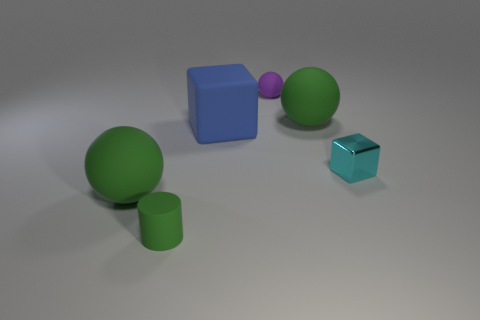Is there a large rubber object that has the same color as the cylinder?
Ensure brevity in your answer.  Yes. There is a rubber cylinder; is it the same color as the sphere that is in front of the cyan thing?
Make the answer very short. Yes. Are there the same number of large green spheres to the right of the tiny cyan block and small green metal cylinders?
Provide a succinct answer. Yes. What number of spheres have the same size as the cyan thing?
Give a very brief answer. 1. Are there any green cylinders?
Your answer should be compact. Yes. There is a large object in front of the blue rubber object; is its shape the same as the big green object that is behind the cyan cube?
Provide a short and direct response. Yes. How many big things are either cyan metallic cubes or green matte objects?
Offer a very short reply. 2. The large blue object that is made of the same material as the small green object is what shape?
Keep it short and to the point. Cube. Is the shape of the blue object the same as the tiny shiny object?
Your answer should be compact. Yes. The shiny object has what color?
Your response must be concise. Cyan. 